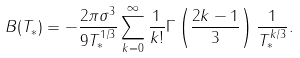Convert formula to latex. <formula><loc_0><loc_0><loc_500><loc_500>B ( T _ { * } ) = - \frac { 2 \pi \sigma ^ { 3 } } { 9 T _ { * } ^ { 1 / 3 } } \sum _ { k = 0 } ^ { \infty } \frac { 1 } { k ! } \Gamma \left ( \frac { 2 k - 1 } { 3 } \right ) \frac { 1 } { T _ { * } ^ { k / 3 } } .</formula> 